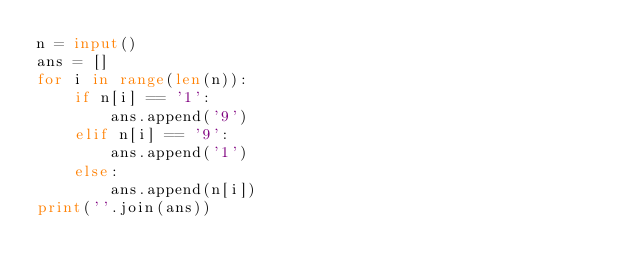<code> <loc_0><loc_0><loc_500><loc_500><_Python_>n = input()
ans = []
for i in range(len(n)):
    if n[i] == '1':
        ans.append('9')
    elif n[i] == '9':
        ans.append('1')
    else:
        ans.append(n[i])
print(''.join(ans))</code> 